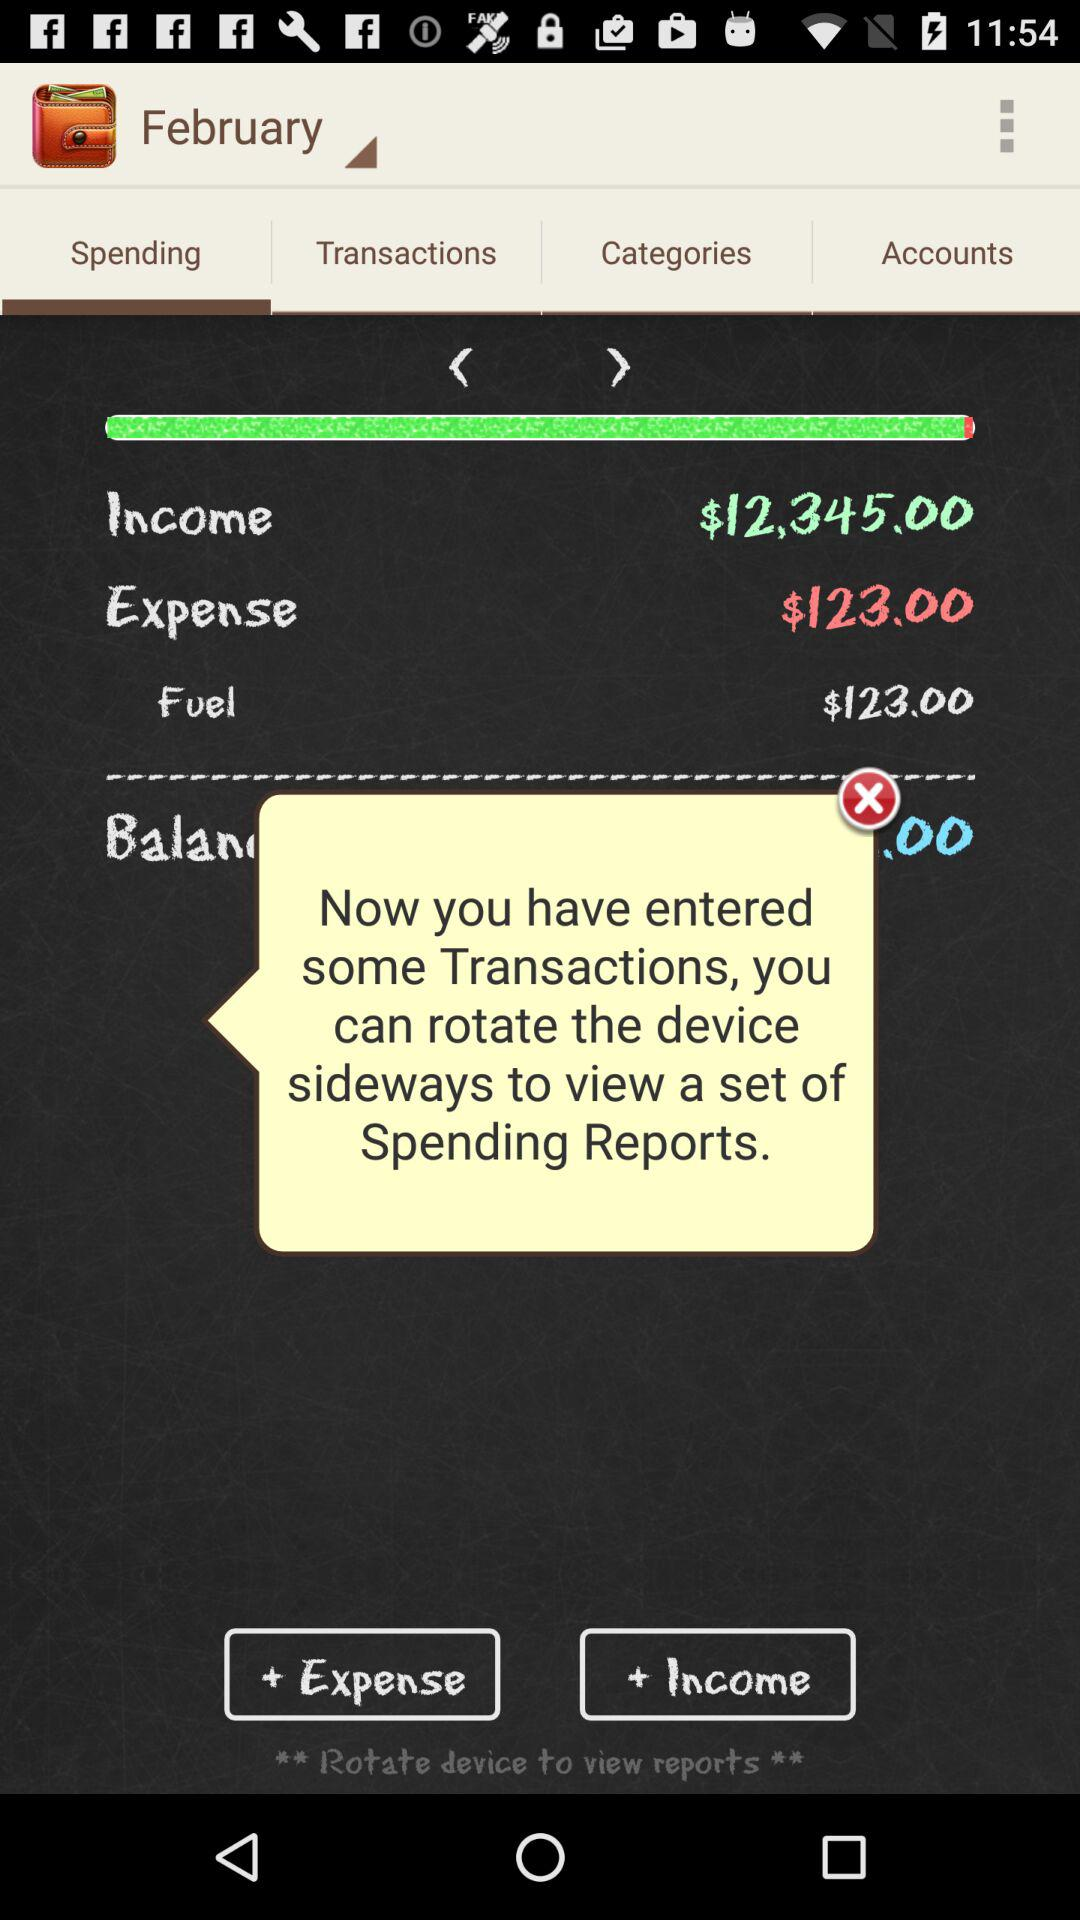What is the income? The income is $12,345. 